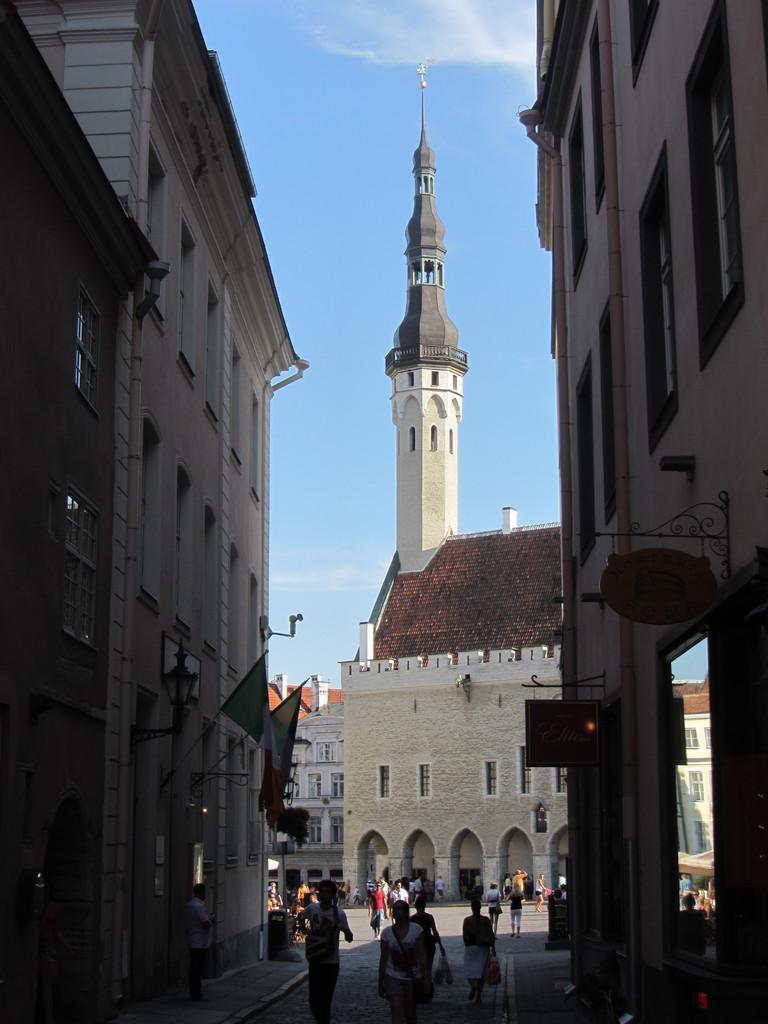Please provide a concise description of this image. In this image I can see the group of people with different color dresses. To the side of these people there are buildings and I can see the flags to one of the building. In the back I can see the blue sky. 